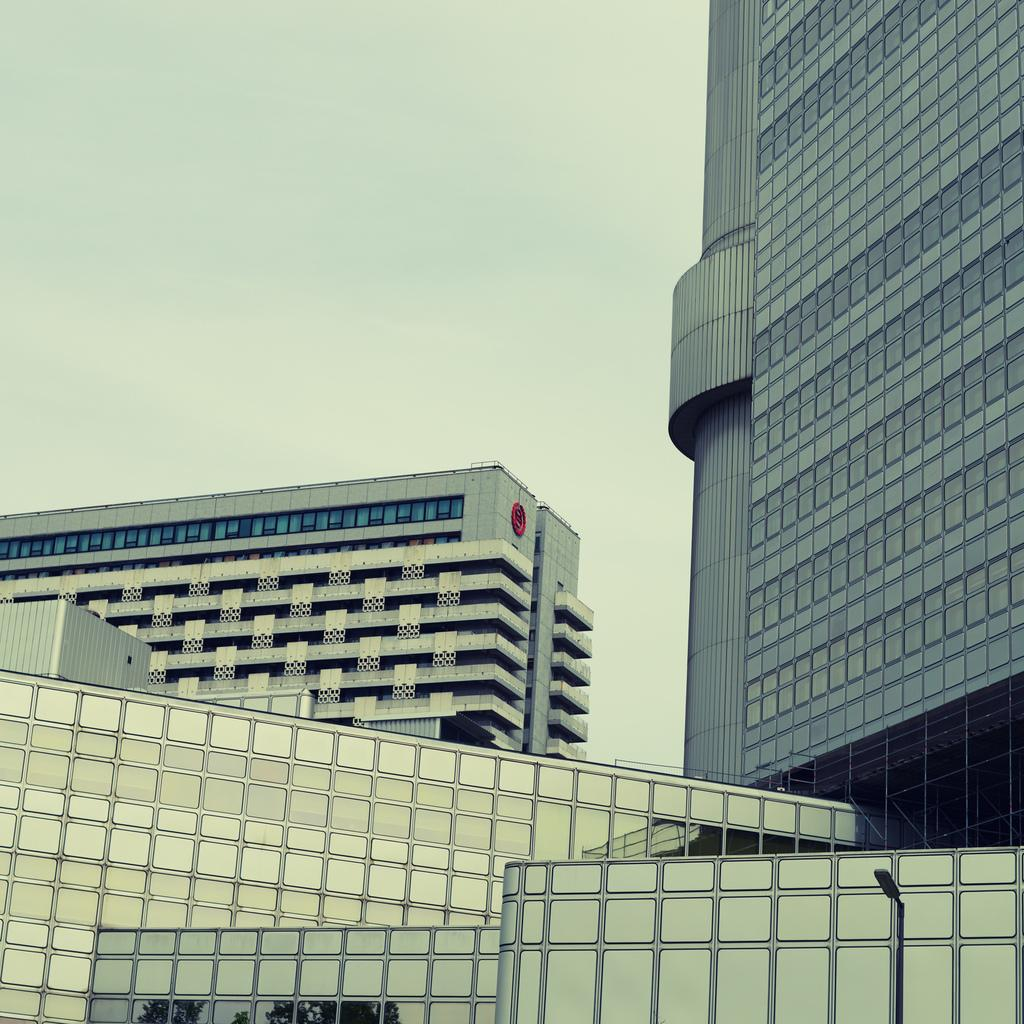What type of structures can be seen in the image? There are buildings in the image. What type of lighting is present in the image? There is a pole light in the image. What is the condition of the sky in the image? The sky is cloudy in the image. How many parcels can be seen on the floor in the image? There is no floor or parcel present in the image; it features buildings and a pole light with a cloudy sky. 